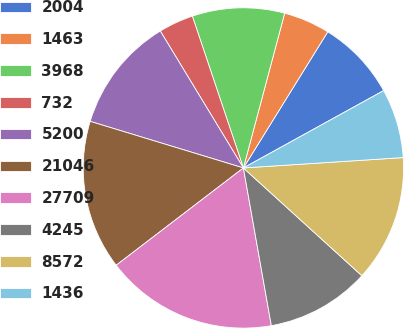Convert chart. <chart><loc_0><loc_0><loc_500><loc_500><pie_chart><fcel>2004<fcel>1463<fcel>3968<fcel>732<fcel>5200<fcel>21046<fcel>27709<fcel>4245<fcel>8572<fcel>1436<nl><fcel>8.15%<fcel>4.68%<fcel>9.31%<fcel>3.52%<fcel>11.62%<fcel>15.09%<fcel>17.4%<fcel>10.46%<fcel>12.78%<fcel>6.99%<nl></chart> 